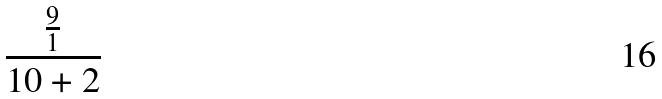Convert formula to latex. <formula><loc_0><loc_0><loc_500><loc_500>\frac { \frac { 9 } { 1 } } { 1 0 + 2 }</formula> 